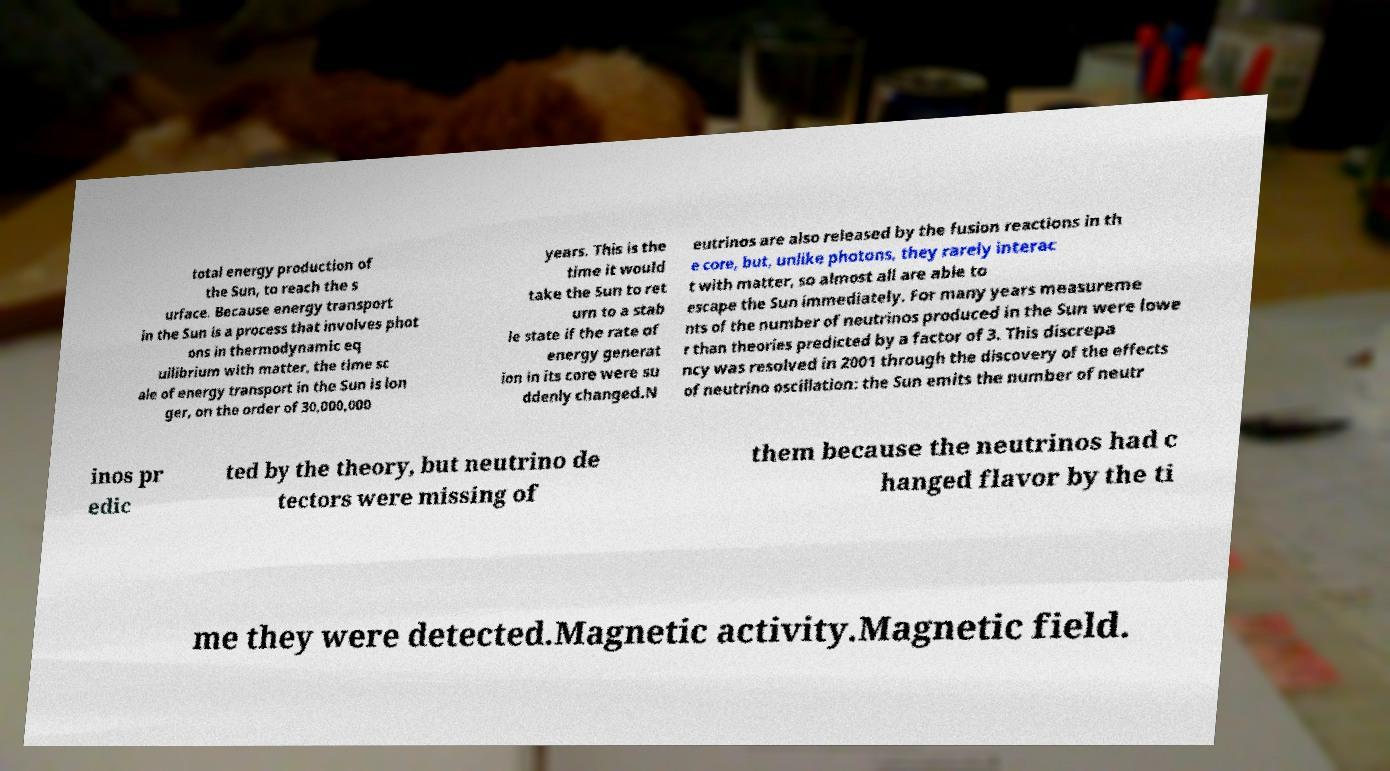Can you accurately transcribe the text from the provided image for me? total energy production of the Sun, to reach the s urface. Because energy transport in the Sun is a process that involves phot ons in thermodynamic eq uilibrium with matter, the time sc ale of energy transport in the Sun is lon ger, on the order of 30,000,000 years. This is the time it would take the Sun to ret urn to a stab le state if the rate of energy generat ion in its core were su ddenly changed.N eutrinos are also released by the fusion reactions in th e core, but, unlike photons, they rarely interac t with matter, so almost all are able to escape the Sun immediately. For many years measureme nts of the number of neutrinos produced in the Sun were lowe r than theories predicted by a factor of 3. This discrepa ncy was resolved in 2001 through the discovery of the effects of neutrino oscillation: the Sun emits the number of neutr inos pr edic ted by the theory, but neutrino de tectors were missing of them because the neutrinos had c hanged flavor by the ti me they were detected.Magnetic activity.Magnetic field. 